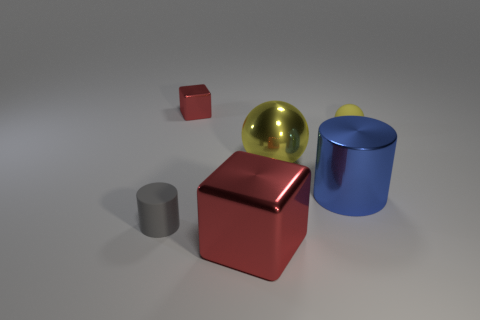Add 1 cyan cubes. How many objects exist? 7 Subtract 0 purple spheres. How many objects are left? 6 Subtract all purple rubber cubes. Subtract all tiny spheres. How many objects are left? 5 Add 5 red objects. How many red objects are left? 7 Add 3 purple things. How many purple things exist? 3 